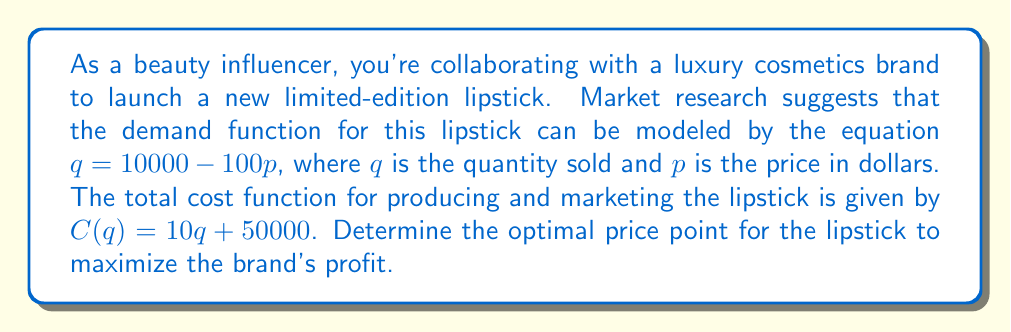Can you solve this math problem? To solve this problem, we'll follow these steps:

1) First, we need to express the revenue and profit functions in terms of price $p$.

2) The demand function is $q = 10000 - 100p$. We can express revenue as $R = pq$:
   
   $R = p(10000 - 100p) = 10000p - 100p^2$

3) The cost function is given in terms of $q$, so we need to substitute the demand function:
   
   $C = 10(10000 - 100p) + 50000 = 100000 - 1000p + 50000 = 150000 - 1000p$

4) Now we can express the profit function $P$ as revenue minus cost:
   
   $P = R - C = (10000p - 100p^2) - (150000 - 1000p)$
   $P = 10000p - 100p^2 - 150000 + 1000p = -100p^2 + 11000p - 150000$

5) To find the maximum profit, we need to find the vertex of this quadratic function. The vertex occurs at the average of the roots of the derivative. Let's find the derivative:

   $\frac{dP}{dp} = -200p + 11000$

6) Set the derivative to zero and solve for $p$:
   
   $-200p + 11000 = 0$
   $-200p = -11000$
   $p = 55$

7) This critical point $p = 55$ gives us the price that maximizes profit. We can verify it's a maximum by checking the second derivative is negative:

   $\frac{d^2P}{dp^2} = -200 < 0$

Therefore, the optimal price point for the lipstick is $55.
Answer: The optimal price point for the limited-edition lipstick to maximize profit is $55. 